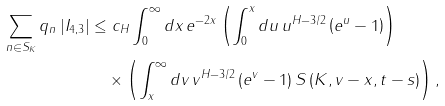<formula> <loc_0><loc_0><loc_500><loc_500>\sum _ { n \in S _ { K } } q _ { n } \left | I _ { 4 , 3 } \right | & \leq c _ { H } \int _ { 0 } ^ { \infty } d x \, e ^ { - 2 x } \left ( \int _ { 0 } ^ { x } d u \, u ^ { H - 3 / 2 } \left ( e ^ { u } - 1 \right ) \right ) \\ & \quad \times \left ( \int _ { x } ^ { \infty } d v \, v ^ { H - 3 / 2 } \left ( e ^ { v } - 1 \right ) S \left ( K , v - x , t - s \right ) \right ) ,</formula> 